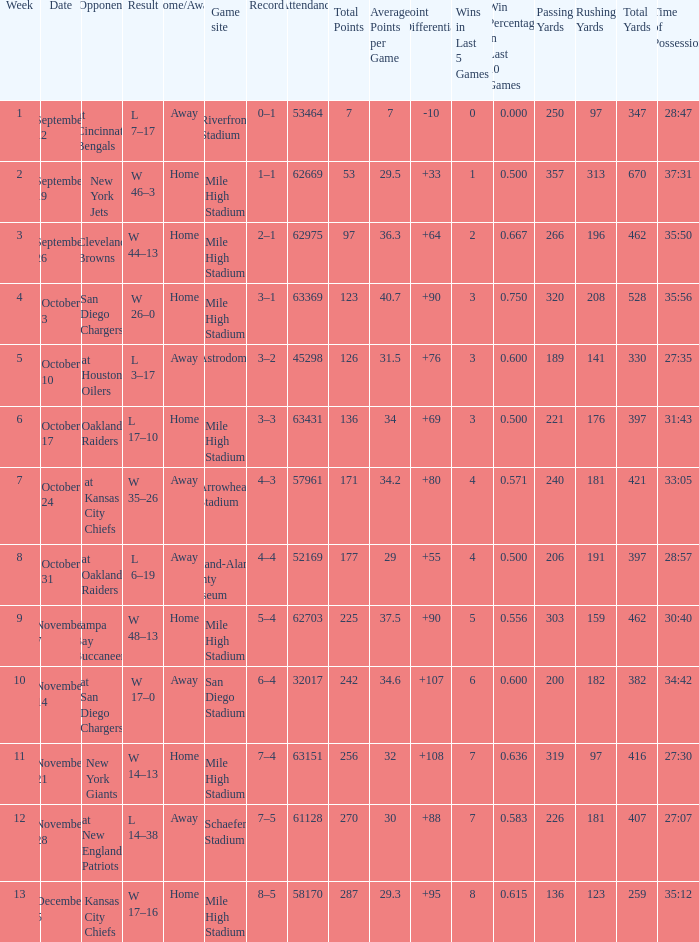What was the week number when the opponent was the New York Jets? 2.0. 